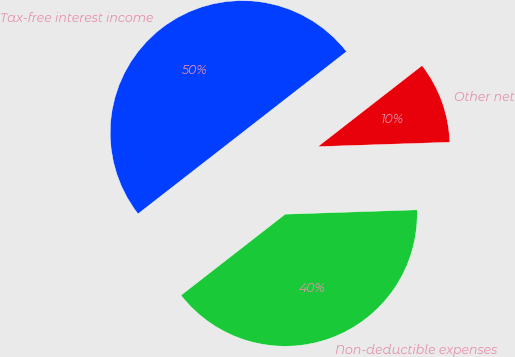Convert chart. <chart><loc_0><loc_0><loc_500><loc_500><pie_chart><fcel>Tax-free interest income<fcel>Non-deductible expenses<fcel>Other net<nl><fcel>50.0%<fcel>40.0%<fcel>10.0%<nl></chart> 